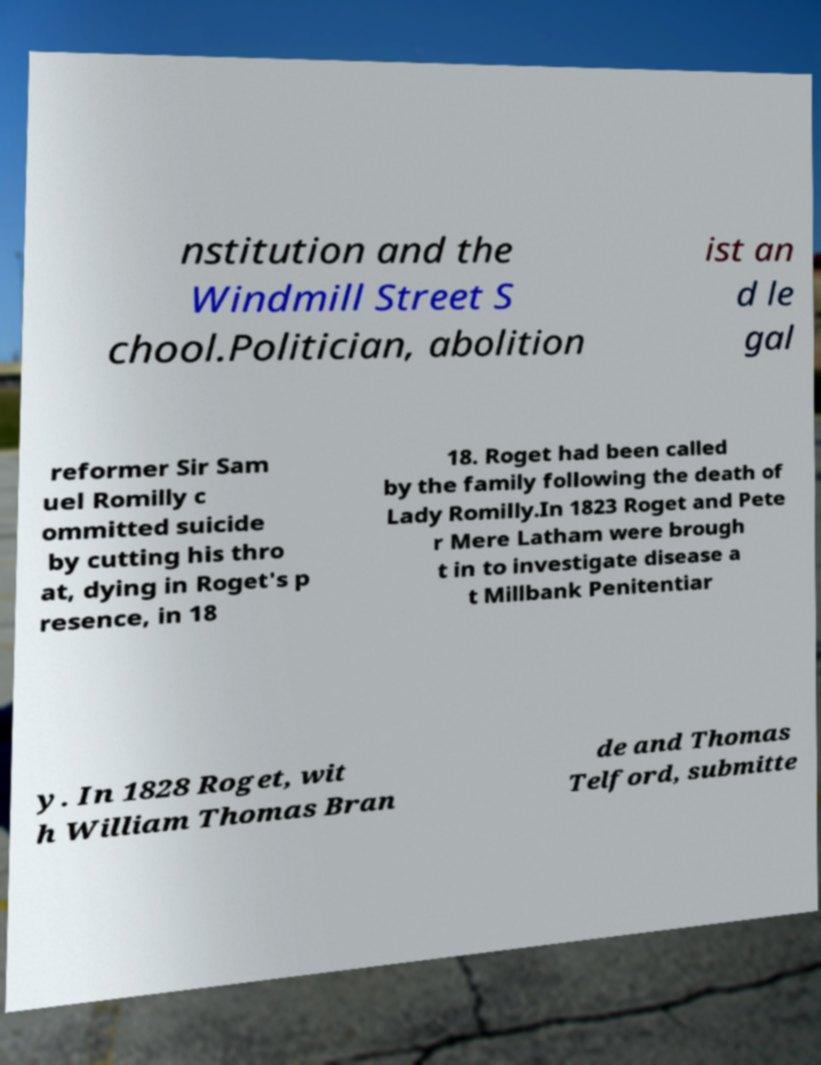Could you extract and type out the text from this image? nstitution and the Windmill Street S chool.Politician, abolition ist an d le gal reformer Sir Sam uel Romilly c ommitted suicide by cutting his thro at, dying in Roget's p resence, in 18 18. Roget had been called by the family following the death of Lady Romilly.In 1823 Roget and Pete r Mere Latham were brough t in to investigate disease a t Millbank Penitentiar y. In 1828 Roget, wit h William Thomas Bran de and Thomas Telford, submitte 